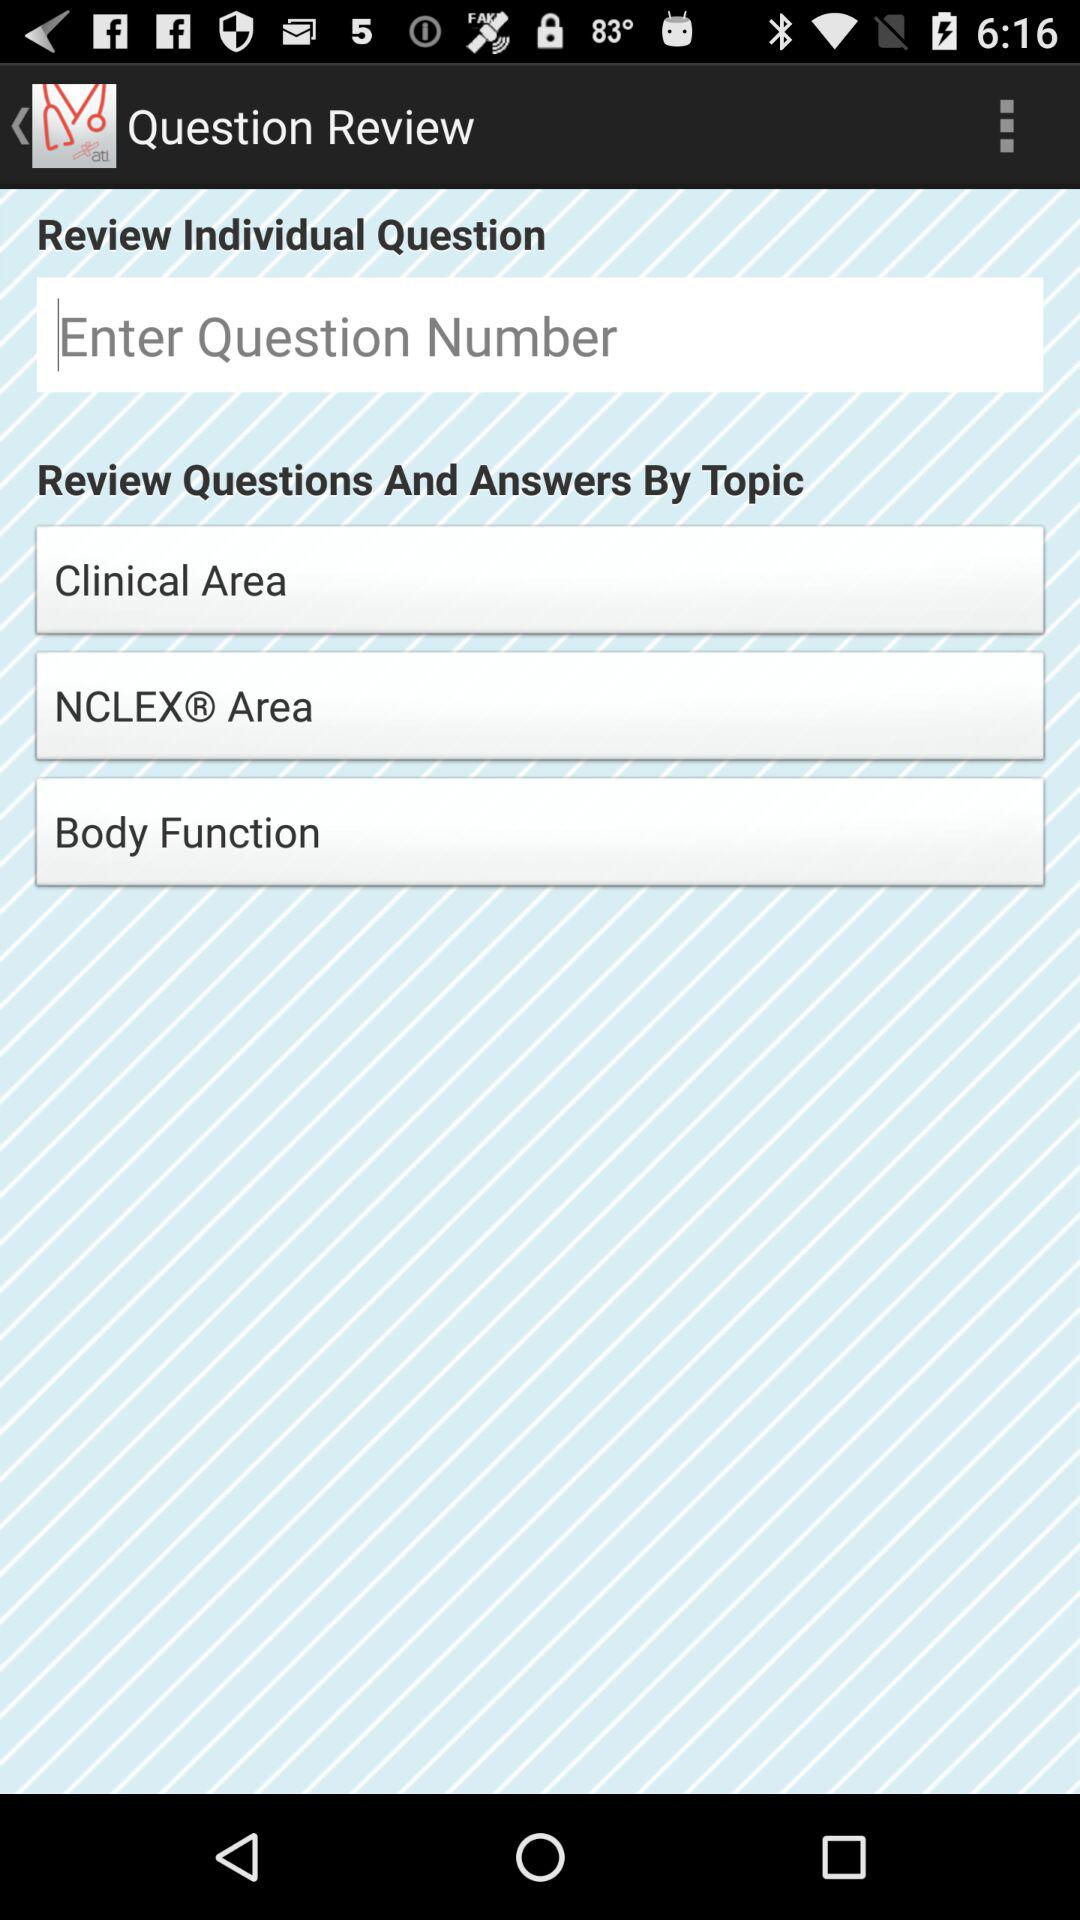How many topics can I review questions and answers by?
Answer the question using a single word or phrase. 3 